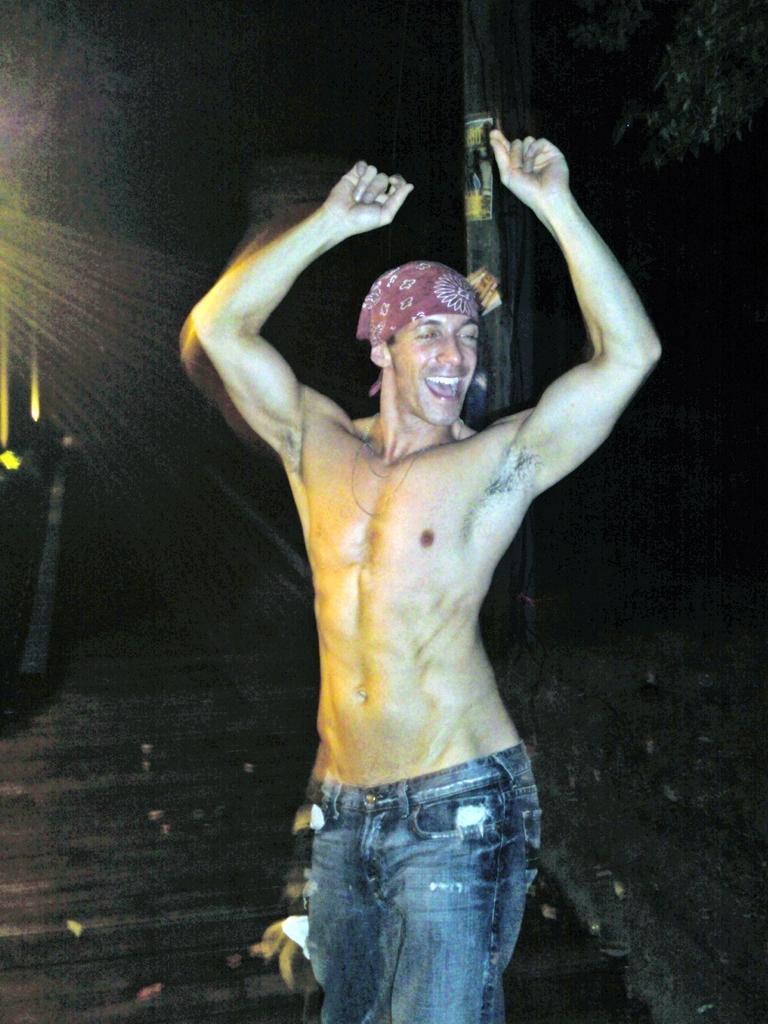Describe this image in one or two sentences. In this image in the front there is a man standing and smiling. In the background there is a pole and on the right side there are leaves. 